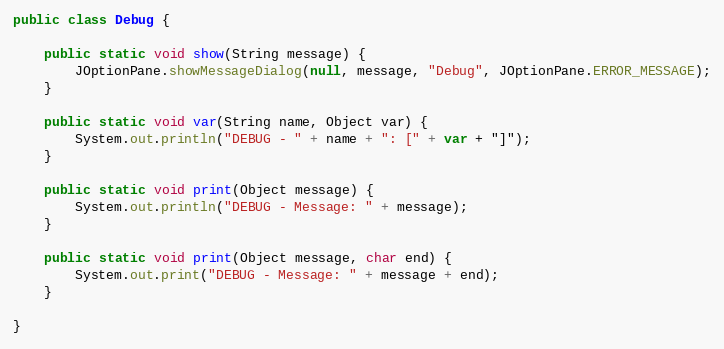<code> <loc_0><loc_0><loc_500><loc_500><_Java_>public class Debug {

    public static void show(String message) {
        JOptionPane.showMessageDialog(null, message, "Debug", JOptionPane.ERROR_MESSAGE);
    }

    public static void var(String name, Object var) {
        System.out.println("DEBUG - " + name + ": [" + var + "]");
    }

    public static void print(Object message) {
        System.out.println("DEBUG - Message: " + message);
    }

    public static void print(Object message, char end) {
        System.out.print("DEBUG - Message: " + message + end);
    }

}
</code> 